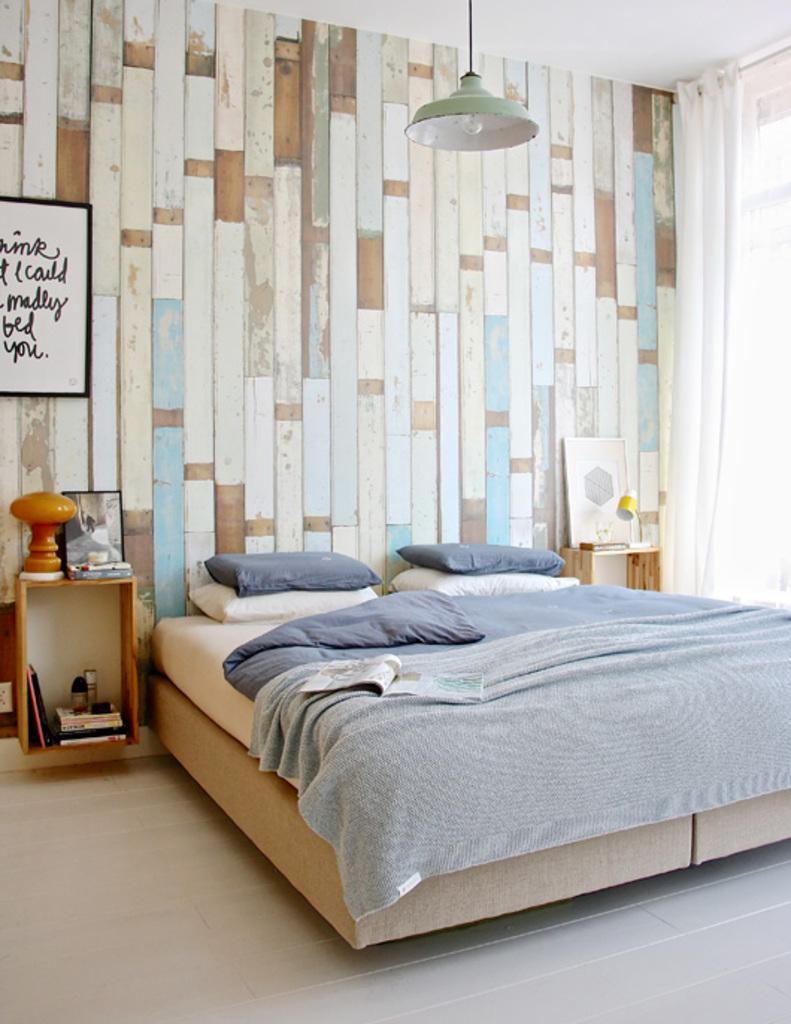Please provide a concise description of this image. In this picture I can see the pillows, blanket on the bed. On the left I can see photo frame, lamp, plastic box, books and bottles on the table. Beside that I can see the socket. In the top left there is a frame which is placed on the wall. At the top I can see the light. On the right I can see the window cloth and window. 